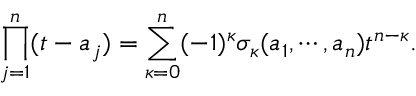Convert formula to latex. <formula><loc_0><loc_0><loc_500><loc_500>\prod _ { j = 1 } ^ { n } ( t - a _ { j } ) = \sum _ { \kappa = 0 } ^ { n } ( - 1 ) ^ { \kappa } \sigma _ { \kappa } ( a _ { 1 } , \cdots , a _ { n } ) t ^ { n - \kappa } .</formula> 